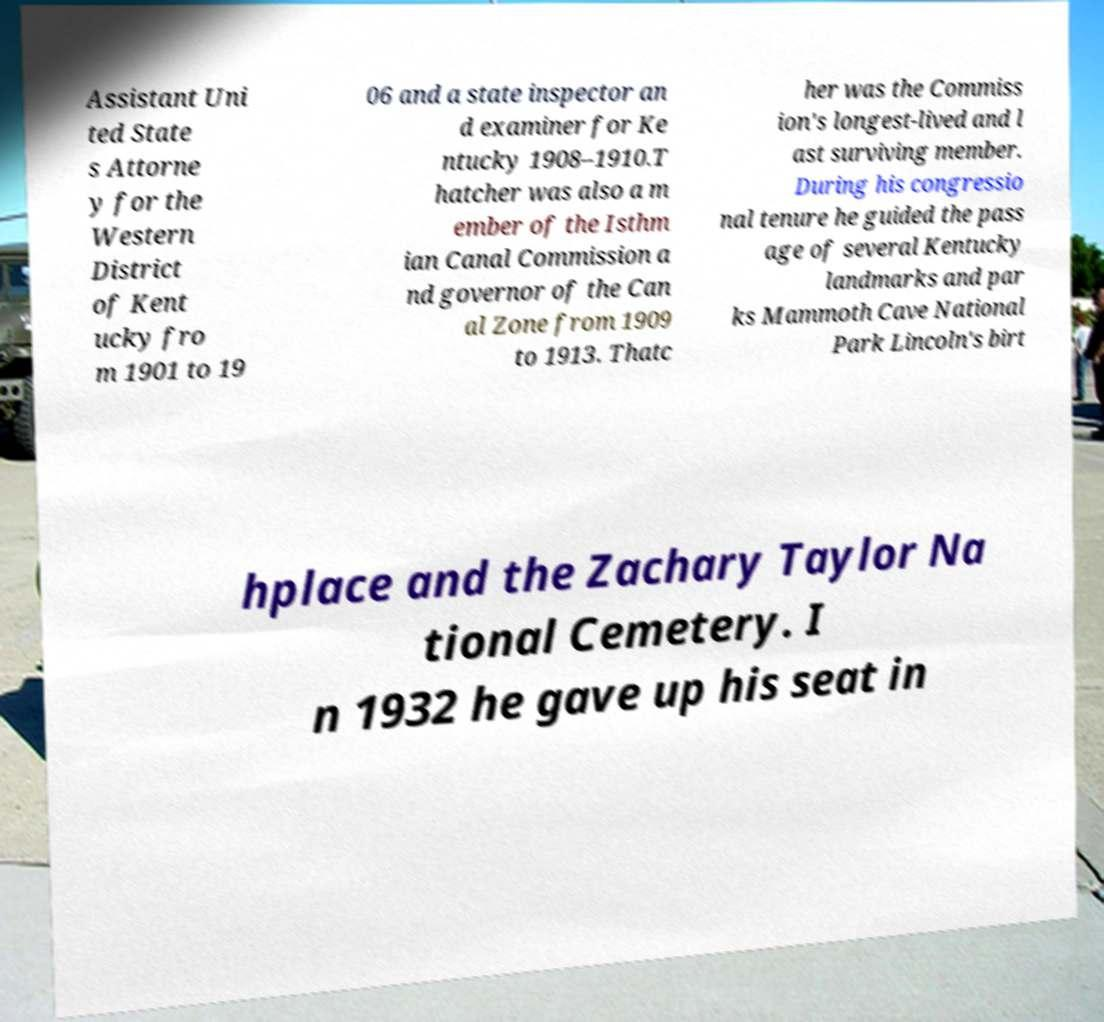Can you read and provide the text displayed in the image?This photo seems to have some interesting text. Can you extract and type it out for me? Assistant Uni ted State s Attorne y for the Western District of Kent ucky fro m 1901 to 19 06 and a state inspector an d examiner for Ke ntucky 1908–1910.T hatcher was also a m ember of the Isthm ian Canal Commission a nd governor of the Can al Zone from 1909 to 1913. Thatc her was the Commiss ion's longest-lived and l ast surviving member. During his congressio nal tenure he guided the pass age of several Kentucky landmarks and par ks Mammoth Cave National Park Lincoln's birt hplace and the Zachary Taylor Na tional Cemetery. I n 1932 he gave up his seat in 